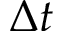<formula> <loc_0><loc_0><loc_500><loc_500>\Delta t</formula> 